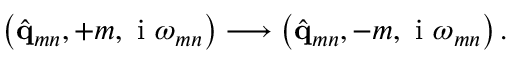Convert formula to latex. <formula><loc_0><loc_0><loc_500><loc_500>\left ( \hat { q } _ { m n } , + m , i \omega _ { m n } \right ) \longrightarrow \left ( \hat { q } _ { m n } , - m , i \omega _ { m n } \right ) .</formula> 